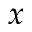<formula> <loc_0><loc_0><loc_500><loc_500>x</formula> 